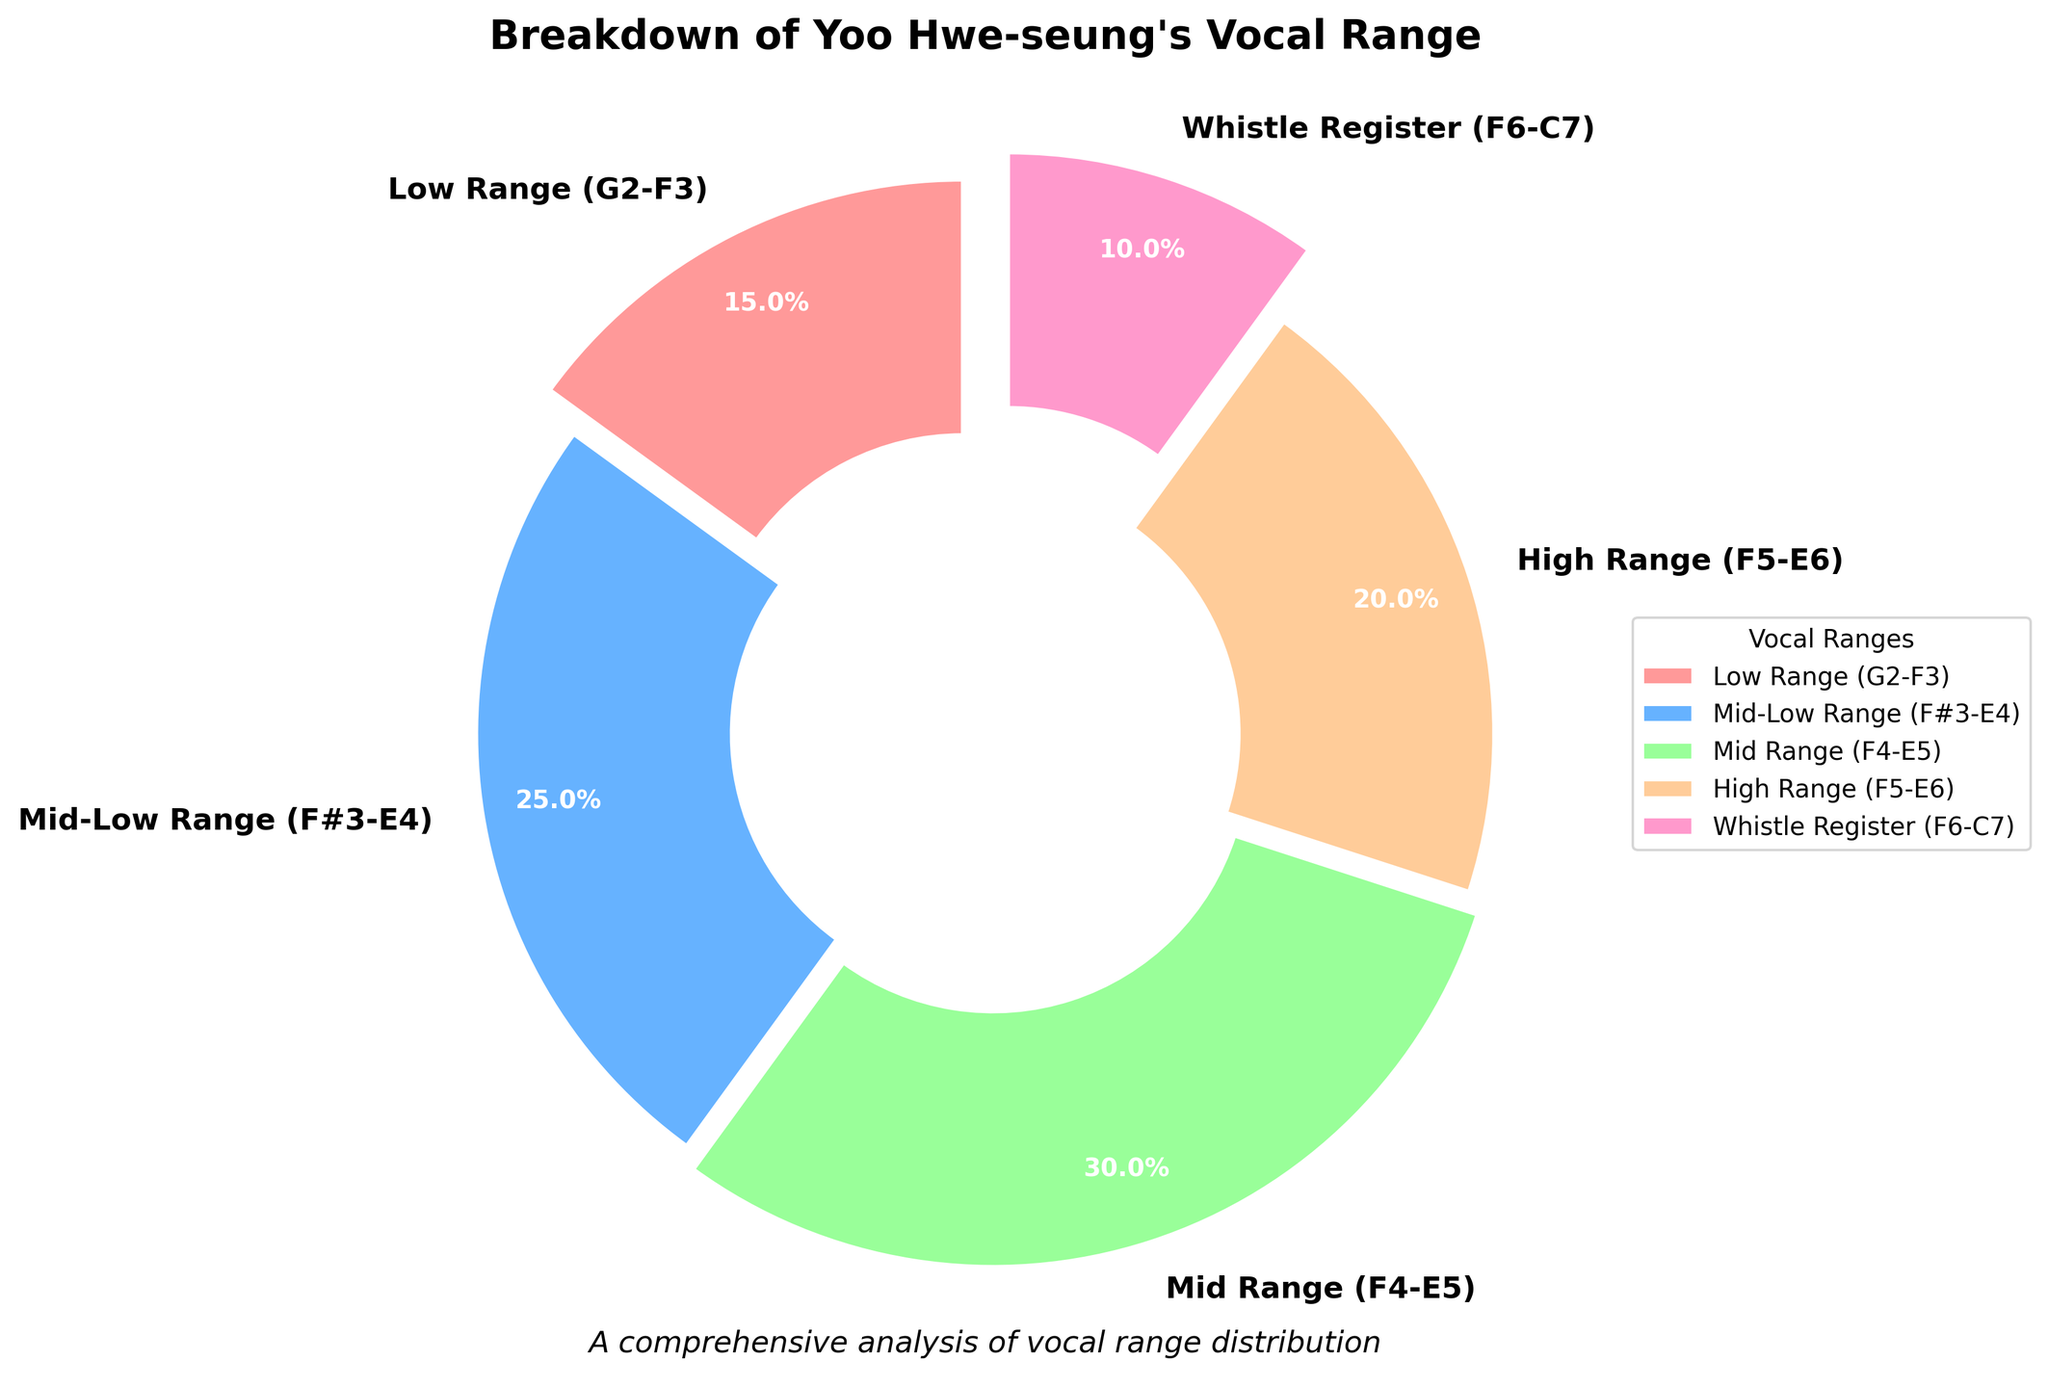How much percentage higher is the Mid Range compared to the Low Range? The Mid Range is represented by 30% and the Low Range by 15%. To find the difference, subtract the Low Range percentage from the Mid Range percentage: 30% - 15% = 15%.
Answer: 15% What is the combined percentage of the Mid-Low Range and the Whistle Register? The Mid-Low Range is 25% and the Whistle Register is 10%. Adding these percentages together, 25% + 10% = 35%.
Answer: 35% Which vocal range occupies the smallest slice of the pie chart? The Whistle Register occupies the smallest slice at 10%.
Answer: Whistle Register Compare the percentages of the High Range and the Mid-Low Range. Which one is greater? The High Range is 20% and the Mid-Low Range is 25%. Therefore, the Mid-Low Range is greater.
Answer: Mid-Low Range What is the difference in percentage between the Mid Range and the High Range? The Mid Range percentage is 30% and the High Range is 20%. Subtract the High Range percentage from the Mid Range percentage: 30% - 20% = 10%.
Answer: 10% Which color represents the Low Range in the pie chart? The Low Range is represented by the color red in the pie chart.
Answer: Red If the Low Range and Mid Range were combined, what would their total percentage be? The Low Range is 15% and the Mid Range is 30%. Adding these percentages gives 15% + 30% = 45%.
Answer: 45% Rank the vocal ranges from highest to lowest percentage. The percentages are: Mid Range (30%), Mid-Low Range (25%), High Range (20%), Low Range (15%), Whistle Register (10%). Ranking them: 1) Mid Range, 2) Mid-Low Range, 3) High Range, 4) Low Range, 5) Whistle Register.
Answer: Mid Range, Mid-Low Range, High Range, Low Range, Whistle Register By how much does the Mid Range exceed the combined total of the Whistle Register and Low Range? The Mid Range is 30%, Whistle Register is 10%, and Low Range is 15%. First, find the combined total of the Whistle Register and Low Range: 10% + 15% = 25%. Then, subtract this from the Mid Range: 30% - 25% = 5%.
Answer: 5% 